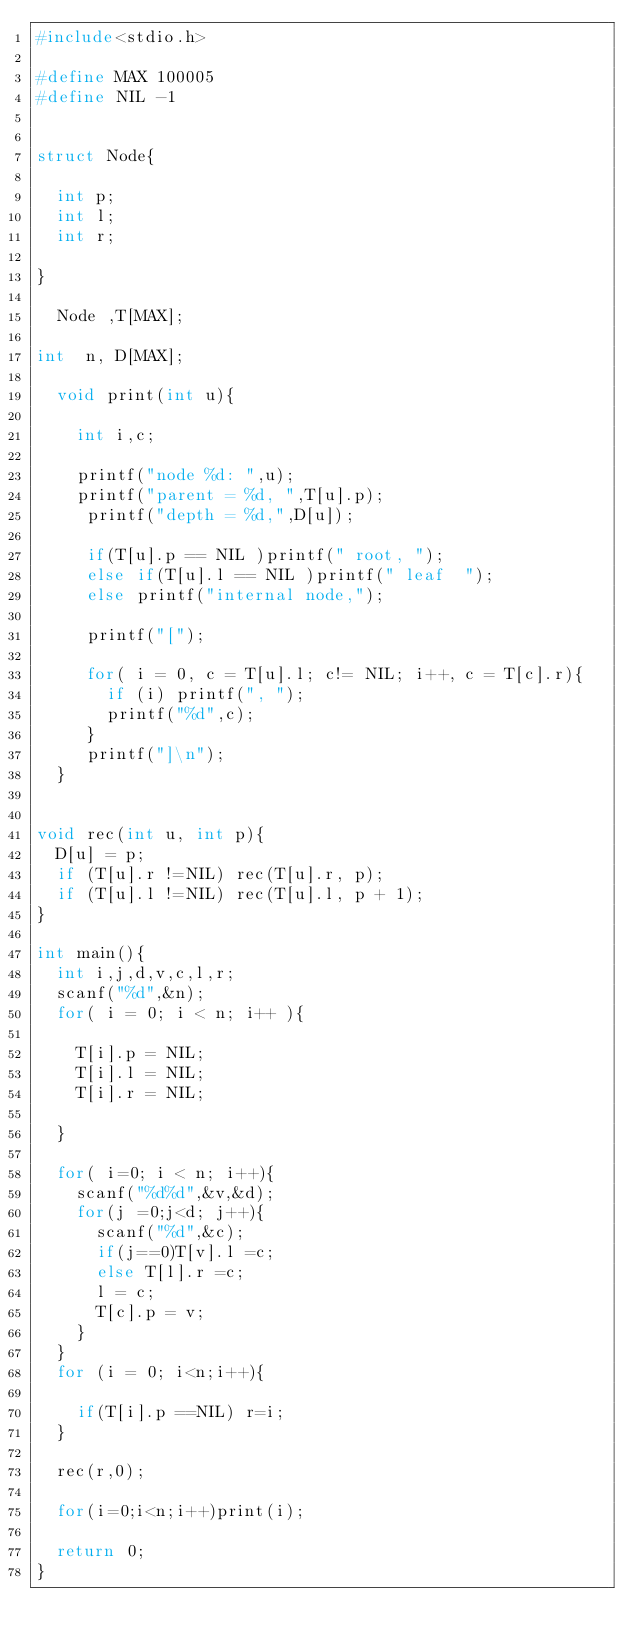Convert code to text. <code><loc_0><loc_0><loc_500><loc_500><_C_>#include<stdio.h>

#define MAX 100005
#define NIL -1


struct Node{

  int p;
  int l;
  int r;

}

  Node ,T[MAX];

int  n, D[MAX];

  void print(int u){

    int i,c;

    printf("node %d: ",u);
    printf("parent = %d, ",T[u].p);
     printf("depth = %d,",D[u]);

     if(T[u].p == NIL )printf(" root, ");
     else if(T[u].l == NIL )printf(" leaf  ");
     else printf("internal node,");

     printf("[");

     for( i = 0, c = T[u].l; c!= NIL; i++, c = T[c].r){
       if (i) printf(", ");
       printf("%d",c);
     }
     printf("]\n");
  }


void rec(int u, int p){
  D[u] = p;
  if (T[u].r !=NIL) rec(T[u].r, p);
  if (T[u].l !=NIL) rec(T[u].l, p + 1);
}

int main(){                              
  int i,j,d,v,c,l,r;                     
  scanf("%d",&n);
  for( i = 0; i < n; i++ ){

    T[i].p = NIL;
    T[i].l = NIL;
    T[i].r = NIL;

  }

  for( i=0; i < n; i++){
    scanf("%d%d",&v,&d);
    for(j =0;j<d; j++){
      scanf("%d",&c);
      if(j==0)T[v].l =c;
      else T[l].r =c;
      l = c;
      T[c].p = v;
    }
  }
  for (i = 0; i<n;i++){

    if(T[i].p ==NIL) r=i;
  }

  rec(r,0);

  for(i=0;i<n;i++)print(i);

  return 0;
}

</code> 